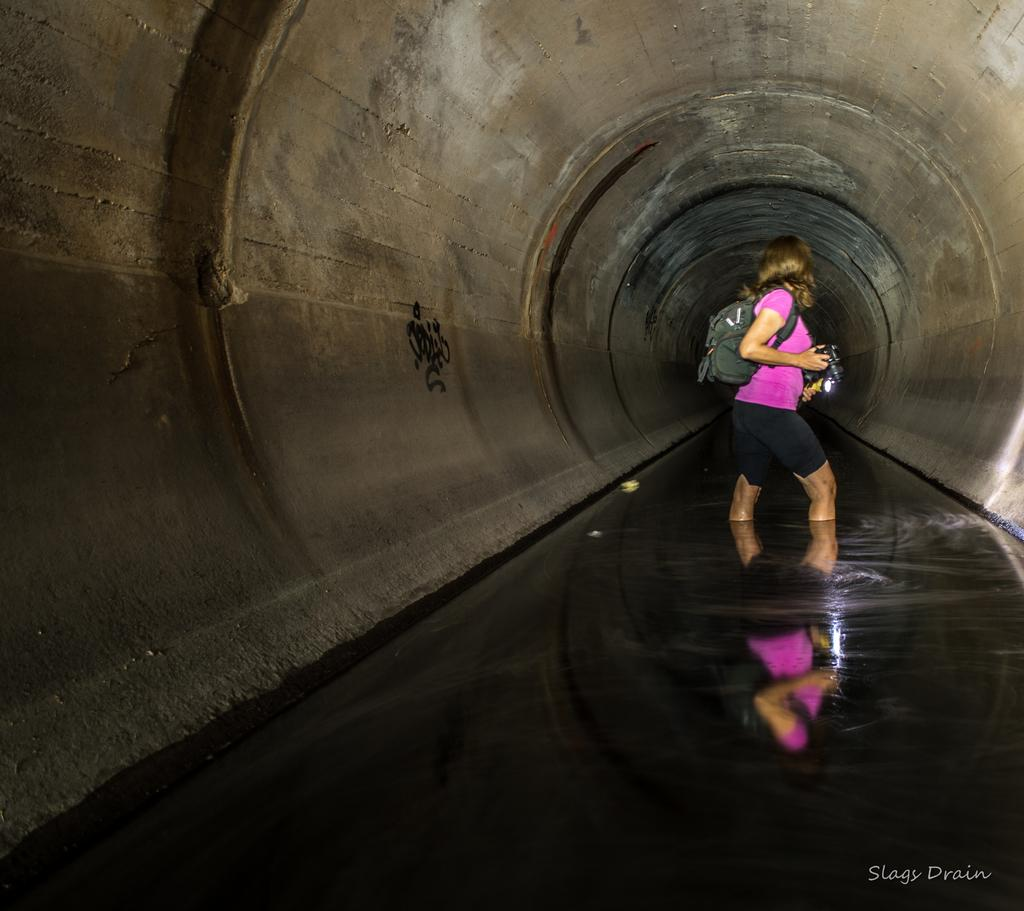Who is present in the image? There is a woman in the image. What is the woman wearing? The woman is wearing a pink dress. Where is the woman located in the image? The woman is standing in a tunnel. What type of pancake is the woman holding in the image? There is no pancake present in the image; the woman is wearing a pink dress and standing in a tunnel. 